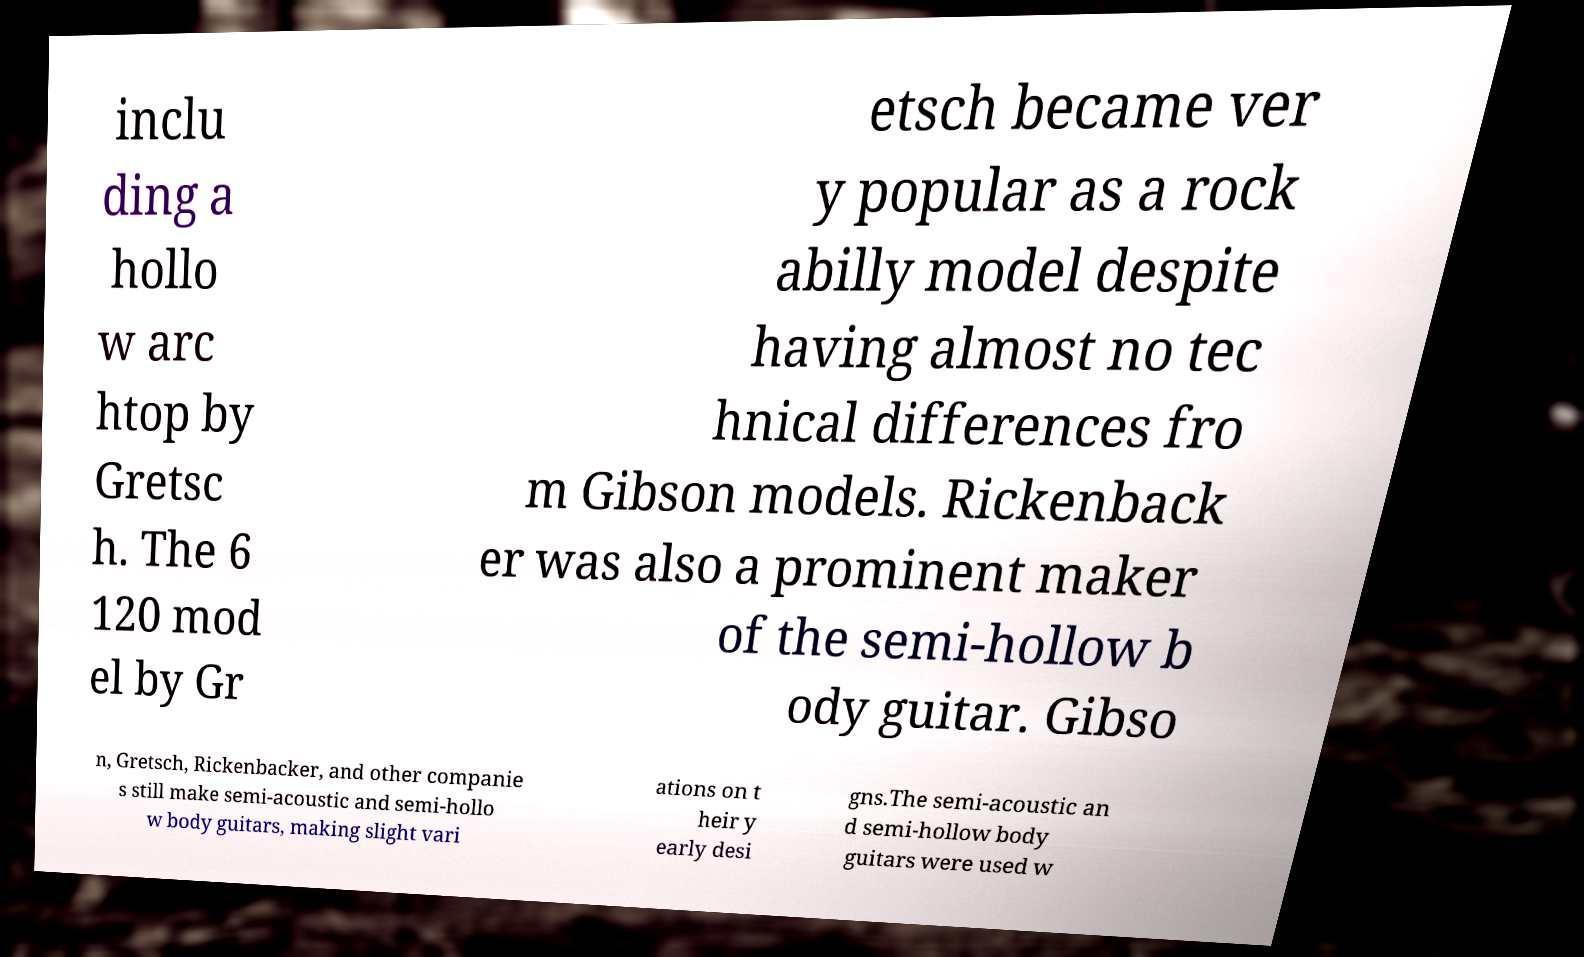Please identify and transcribe the text found in this image. inclu ding a hollo w arc htop by Gretsc h. The 6 120 mod el by Gr etsch became ver y popular as a rock abilly model despite having almost no tec hnical differences fro m Gibson models. Rickenback er was also a prominent maker of the semi-hollow b ody guitar. Gibso n, Gretsch, Rickenbacker, and other companie s still make semi-acoustic and semi-hollo w body guitars, making slight vari ations on t heir y early desi gns.The semi-acoustic an d semi-hollow body guitars were used w 